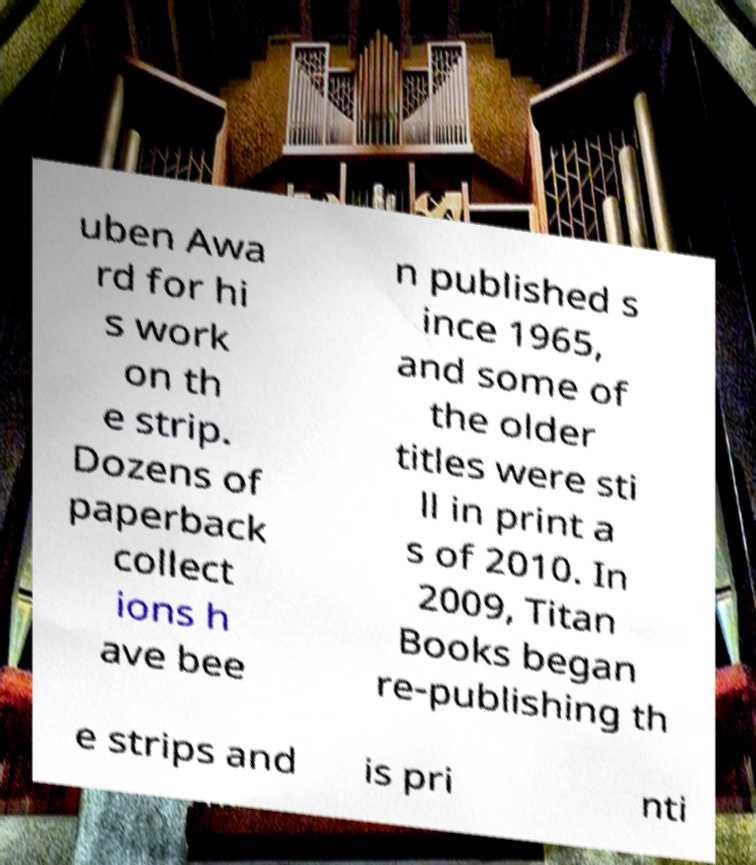Can you read and provide the text displayed in the image?This photo seems to have some interesting text. Can you extract and type it out for me? uben Awa rd for hi s work on th e strip. Dozens of paperback collect ions h ave bee n published s ince 1965, and some of the older titles were sti ll in print a s of 2010. In 2009, Titan Books began re-publishing th e strips and is pri nti 